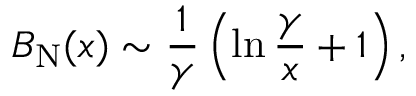<formula> <loc_0><loc_0><loc_500><loc_500>B _ { N } ( x ) \sim { \frac { 1 } { \gamma } } \left ( \ln { \frac { \gamma } { x } } + 1 \right ) ,</formula> 